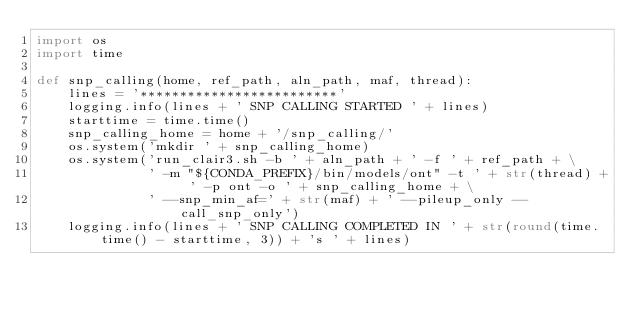<code> <loc_0><loc_0><loc_500><loc_500><_Python_>import os
import time

def snp_calling(home, ref_path, aln_path, maf, thread):
    lines = '*************************'
    logging.info(lines + ' SNP CALLING STARTED ' + lines)
    starttime = time.time()
    snp_calling_home = home + '/snp_calling/'
    os.system('mkdir ' + snp_calling_home)
    os.system('run_clair3.sh -b ' + aln_path + ' -f ' + ref_path + \
              ' -m "${CONDA_PREFIX}/bin/models/ont" -t ' + str(thread) + ' -p ont -o ' + snp_calling_home + \
              ' --snp_min_af=' + str(maf) + ' --pileup_only --call_snp_only')
    logging.info(lines + ' SNP CALLING COMPLETED IN ' + str(round(time.time() - starttime, 3)) + 's ' + lines)</code> 